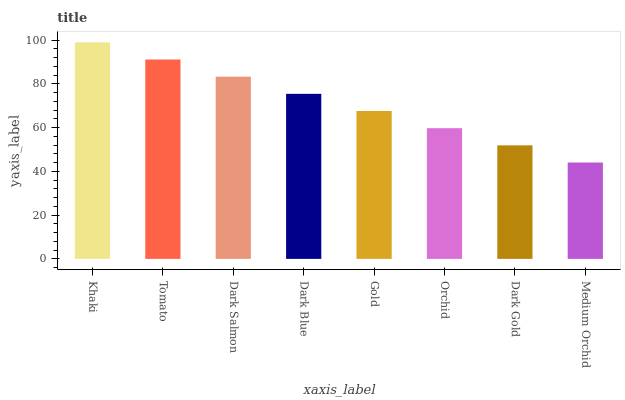Is Medium Orchid the minimum?
Answer yes or no. Yes. Is Khaki the maximum?
Answer yes or no. Yes. Is Tomato the minimum?
Answer yes or no. No. Is Tomato the maximum?
Answer yes or no. No. Is Khaki greater than Tomato?
Answer yes or no. Yes. Is Tomato less than Khaki?
Answer yes or no. Yes. Is Tomato greater than Khaki?
Answer yes or no. No. Is Khaki less than Tomato?
Answer yes or no. No. Is Dark Blue the high median?
Answer yes or no. Yes. Is Gold the low median?
Answer yes or no. Yes. Is Gold the high median?
Answer yes or no. No. Is Dark Blue the low median?
Answer yes or no. No. 